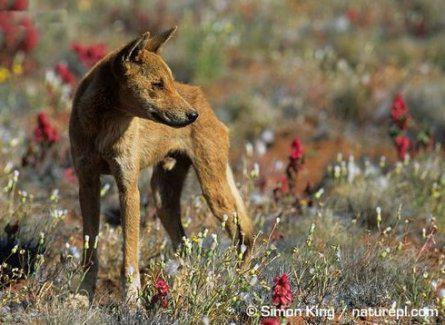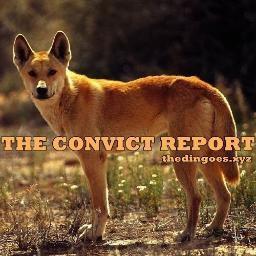The first image is the image on the left, the second image is the image on the right. Considering the images on both sides, is "A dingo is surrounded by a grass and flowered ground cover" valid? Answer yes or no. Yes. The first image is the image on the left, the second image is the image on the right. Assess this claim about the two images: "Each image shows a single dingo standing on all fours, and the dingo on the right has its body turned leftward.". Correct or not? Answer yes or no. Yes. 